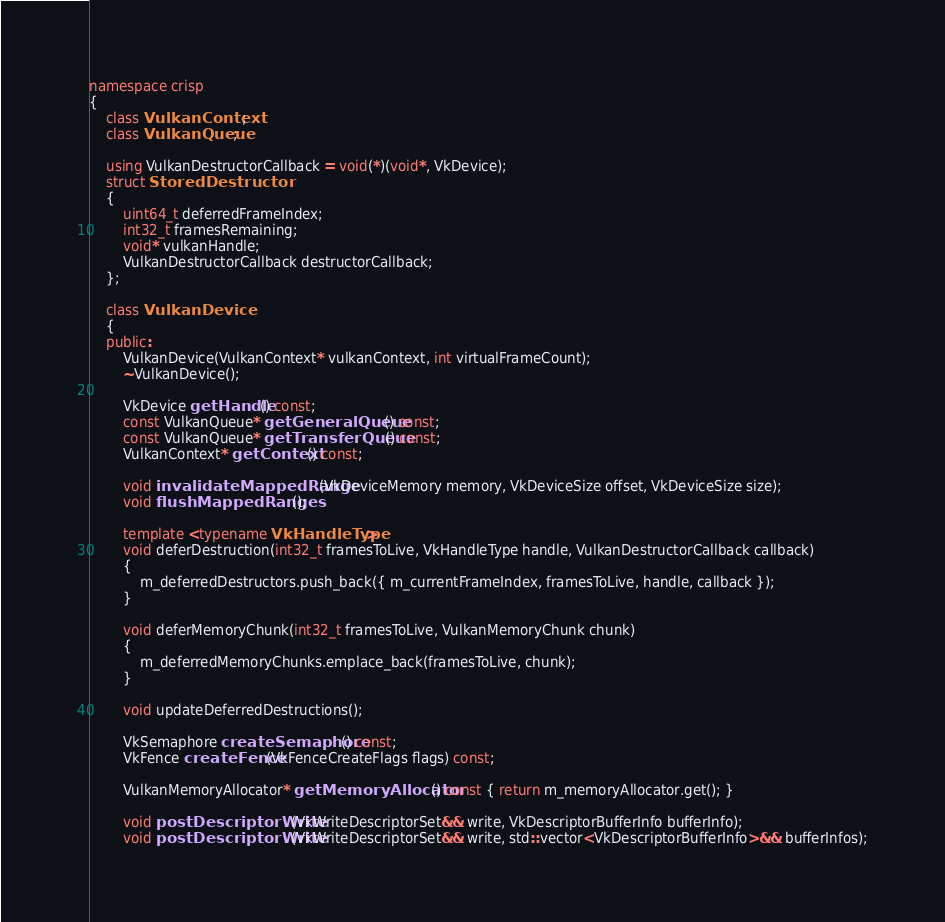<code> <loc_0><loc_0><loc_500><loc_500><_C++_>
namespace crisp
{
    class VulkanContext;
    class VulkanQueue;

    using VulkanDestructorCallback = void(*)(void*, VkDevice);
    struct StoredDestructor
    {
        uint64_t deferredFrameIndex;
        int32_t framesRemaining;
        void* vulkanHandle;
        VulkanDestructorCallback destructorCallback;
    };

    class VulkanDevice
    {
    public:
        VulkanDevice(VulkanContext* vulkanContext, int virtualFrameCount);
        ~VulkanDevice();

        VkDevice getHandle() const;
        const VulkanQueue* getGeneralQueue() const;
        const VulkanQueue* getTransferQueue() const;
        VulkanContext* getContext() const;

        void invalidateMappedRange(VkDeviceMemory memory, VkDeviceSize offset, VkDeviceSize size);
        void flushMappedRanges();

        template <typename VkHandleType>
        void deferDestruction(int32_t framesToLive, VkHandleType handle, VulkanDestructorCallback callback)
        {
            m_deferredDestructors.push_back({ m_currentFrameIndex, framesToLive, handle, callback });
        }

        void deferMemoryChunk(int32_t framesToLive, VulkanMemoryChunk chunk)
        {
            m_deferredMemoryChunks.emplace_back(framesToLive, chunk);
        }

        void updateDeferredDestructions();

        VkSemaphore createSemaphore() const;
        VkFence createFence(VkFenceCreateFlags flags) const;

        VulkanMemoryAllocator* getMemoryAllocator() const { return m_memoryAllocator.get(); }

        void postDescriptorWrite(VkWriteDescriptorSet&& write, VkDescriptorBufferInfo bufferInfo);
        void postDescriptorWrite(VkWriteDescriptorSet&& write, std::vector<VkDescriptorBufferInfo>&& bufferInfos);</code> 